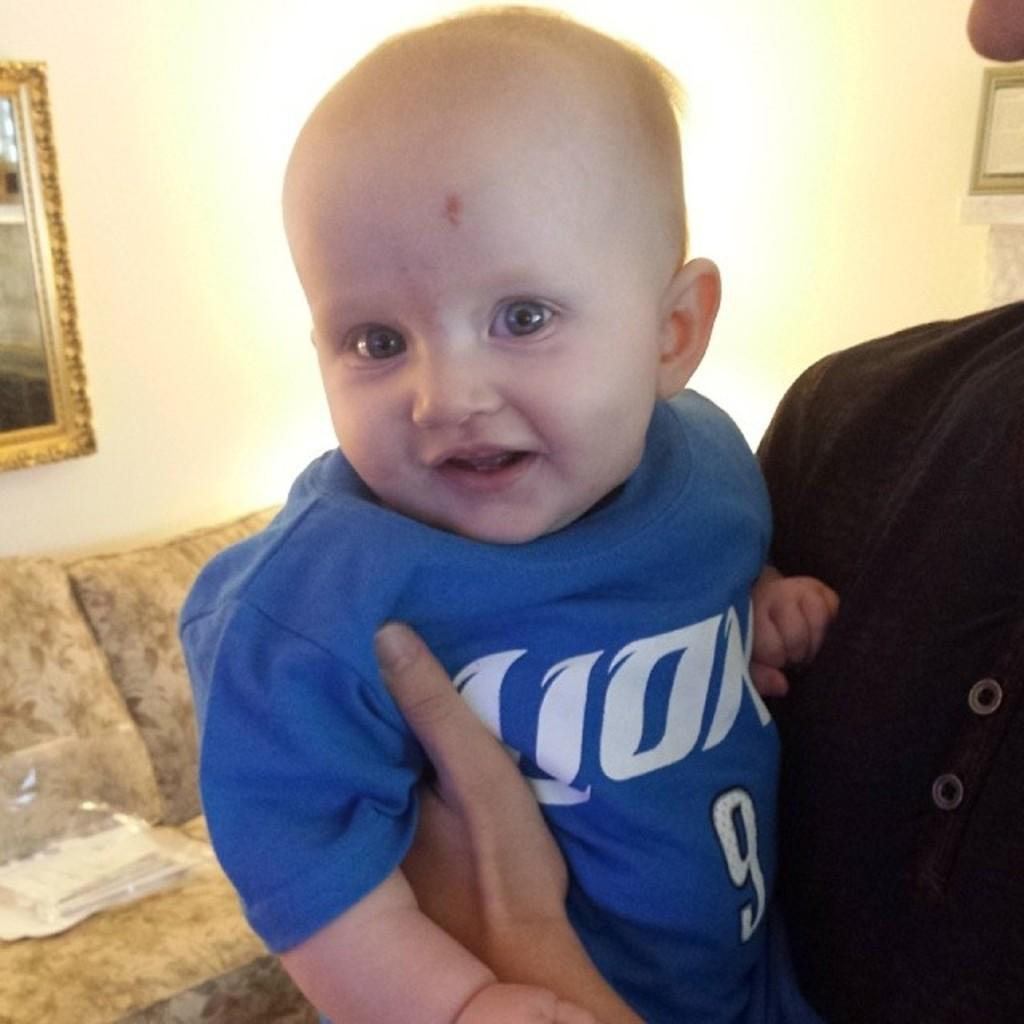<image>
Share a concise interpretation of the image provided. A young boy wears a blue shirt with the number 9 on it. 